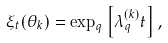<formula> <loc_0><loc_0><loc_500><loc_500>\xi _ { t } ( \theta _ { k } ) = \exp _ { q } \left [ \lambda _ { q } ^ { ( k ) } t \right ] ,</formula> 